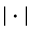Convert formula to latex. <formula><loc_0><loc_0><loc_500><loc_500>| \cdot |</formula> 